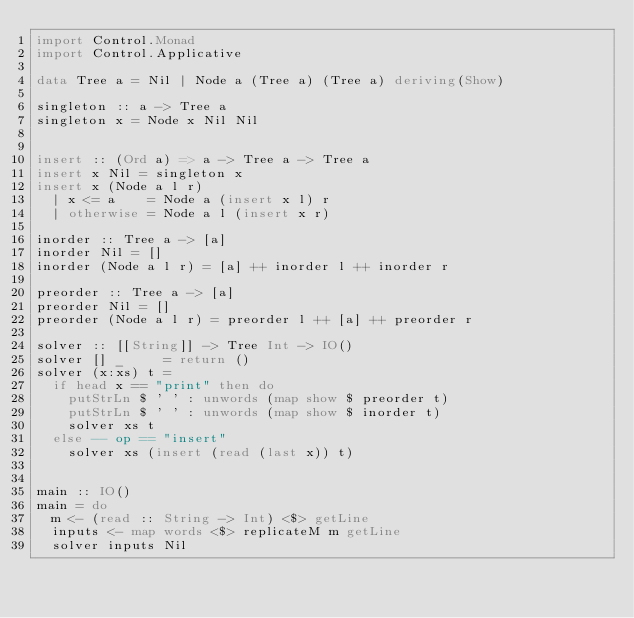<code> <loc_0><loc_0><loc_500><loc_500><_Haskell_>import Control.Monad
import Control.Applicative

data Tree a = Nil | Node a (Tree a) (Tree a) deriving(Show)

singleton :: a -> Tree a
singleton x = Node x Nil Nil


insert :: (Ord a) => a -> Tree a -> Tree a
insert x Nil = singleton x
insert x (Node a l r)
  | x <= a    = Node a (insert x l) r
  | otherwise = Node a l (insert x r)

inorder :: Tree a -> [a]
inorder Nil = []
inorder (Node a l r) = [a] ++ inorder l ++ inorder r

preorder :: Tree a -> [a]
preorder Nil = []
preorder (Node a l r) = preorder l ++ [a] ++ preorder r

solver :: [[String]] -> Tree Int -> IO()
solver [] _     = return ()
solver (x:xs) t =
  if head x == "print" then do
    putStrLn $ ' ' : unwords (map show $ preorder t)
    putStrLn $ ' ' : unwords (map show $ inorder t)
    solver xs t
  else -- op == "insert"
    solver xs (insert (read (last x)) t)


main :: IO()
main = do
  m <- (read :: String -> Int) <$> getLine
  inputs <- map words <$> replicateM m getLine
  solver inputs Nil</code> 